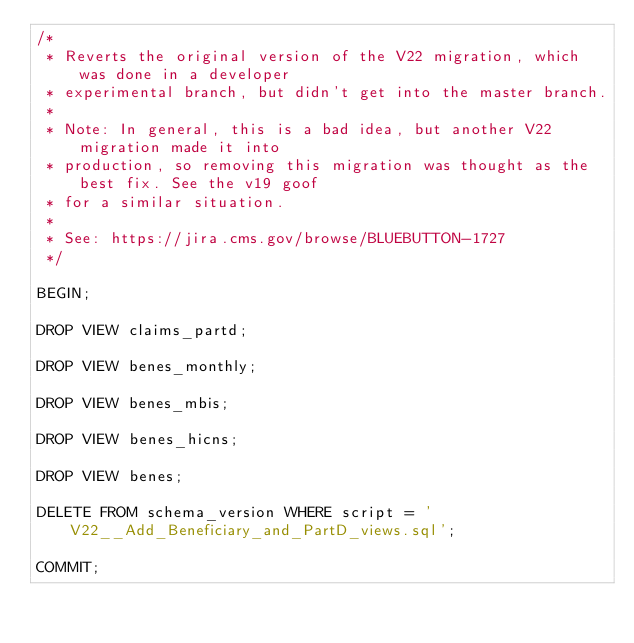Convert code to text. <code><loc_0><loc_0><loc_500><loc_500><_SQL_>/*
 * Reverts the original version of the V22 migration, which was done in a developer
 * experimental branch, but didn't get into the master branch.
 *
 * Note: In general, this is a bad idea, but another V22 migration made it into
 * production, so removing this migration was thought as the best fix. See the v19 goof
 * for a similar situation.
 *
 * See: https://jira.cms.gov/browse/BLUEBUTTON-1727
 */

BEGIN;

DROP VIEW claims_partd;

DROP VIEW benes_monthly;

DROP VIEW benes_mbis;

DROP VIEW benes_hicns;

DROP VIEW benes;

DELETE FROM schema_version WHERE script = 'V22__Add_Beneficiary_and_PartD_views.sql';

COMMIT;
</code> 